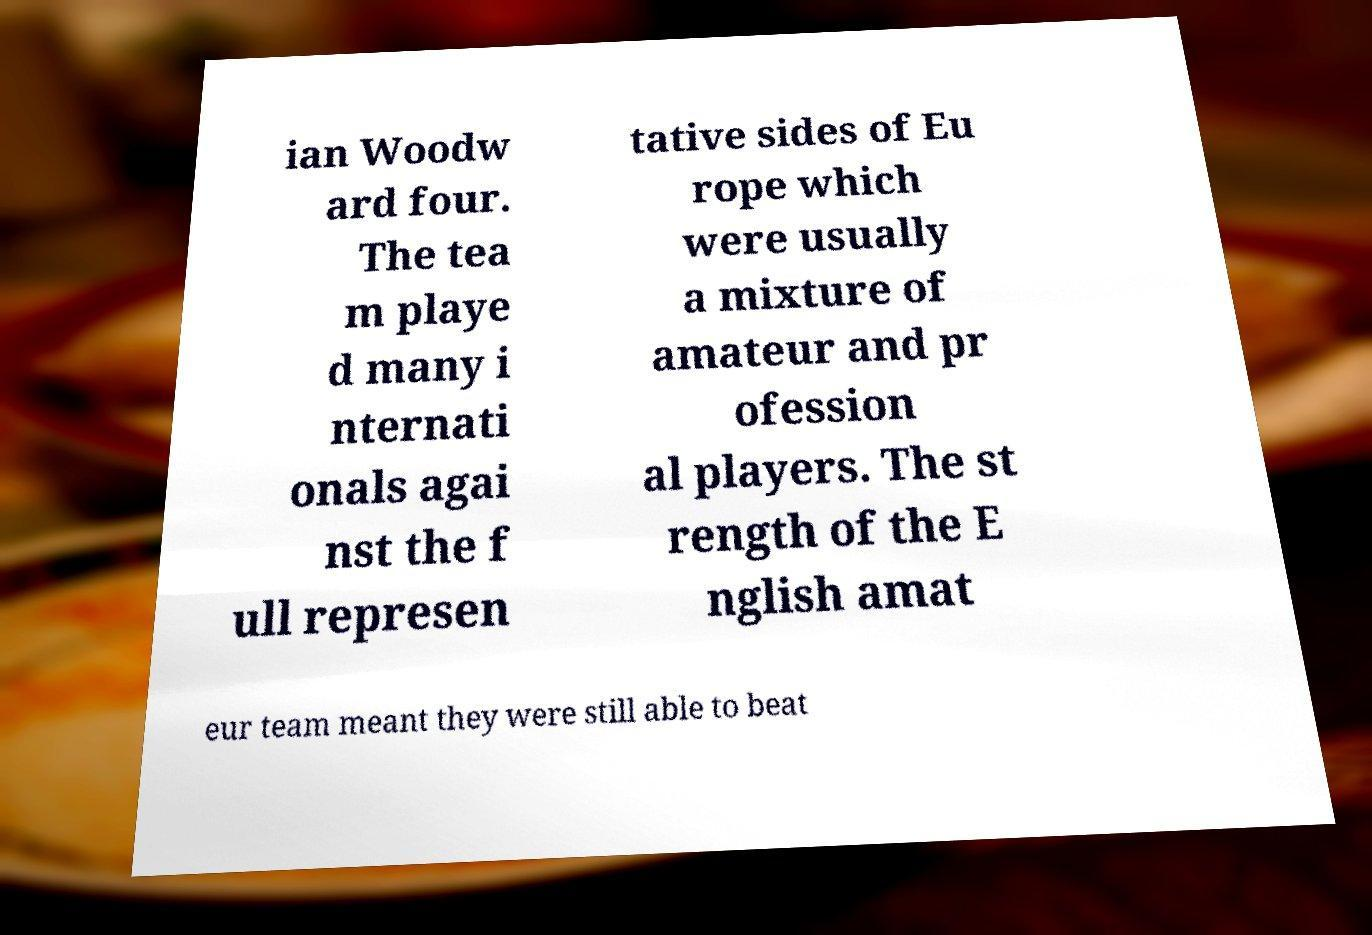There's text embedded in this image that I need extracted. Can you transcribe it verbatim? ian Woodw ard four. The tea m playe d many i nternati onals agai nst the f ull represen tative sides of Eu rope which were usually a mixture of amateur and pr ofession al players. The st rength of the E nglish amat eur team meant they were still able to beat 